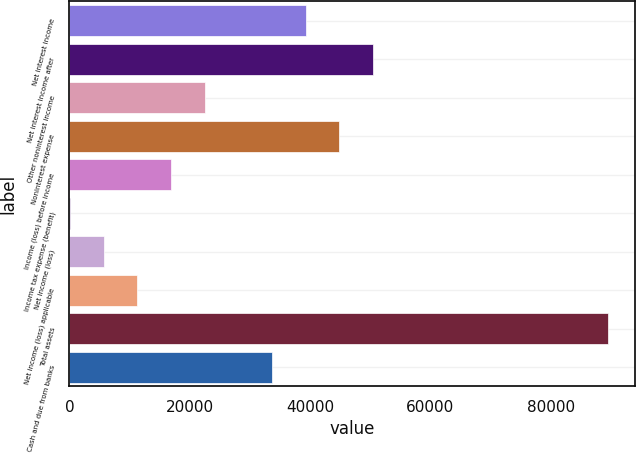Convert chart to OTSL. <chart><loc_0><loc_0><loc_500><loc_500><bar_chart><fcel>Net interest income<fcel>Net interest income after<fcel>Other noninterest income<fcel>Noninterest expense<fcel>Income (loss) before income<fcel>Income tax expense (benefit)<fcel>Net income (loss)<fcel>Net income (loss) applicable<fcel>Total assets<fcel>Cash and due from banks<nl><fcel>39264.6<fcel>50442.2<fcel>22498.1<fcel>44853.4<fcel>16909.3<fcel>142.9<fcel>5731.71<fcel>11320.5<fcel>89563.9<fcel>33675.8<nl></chart> 